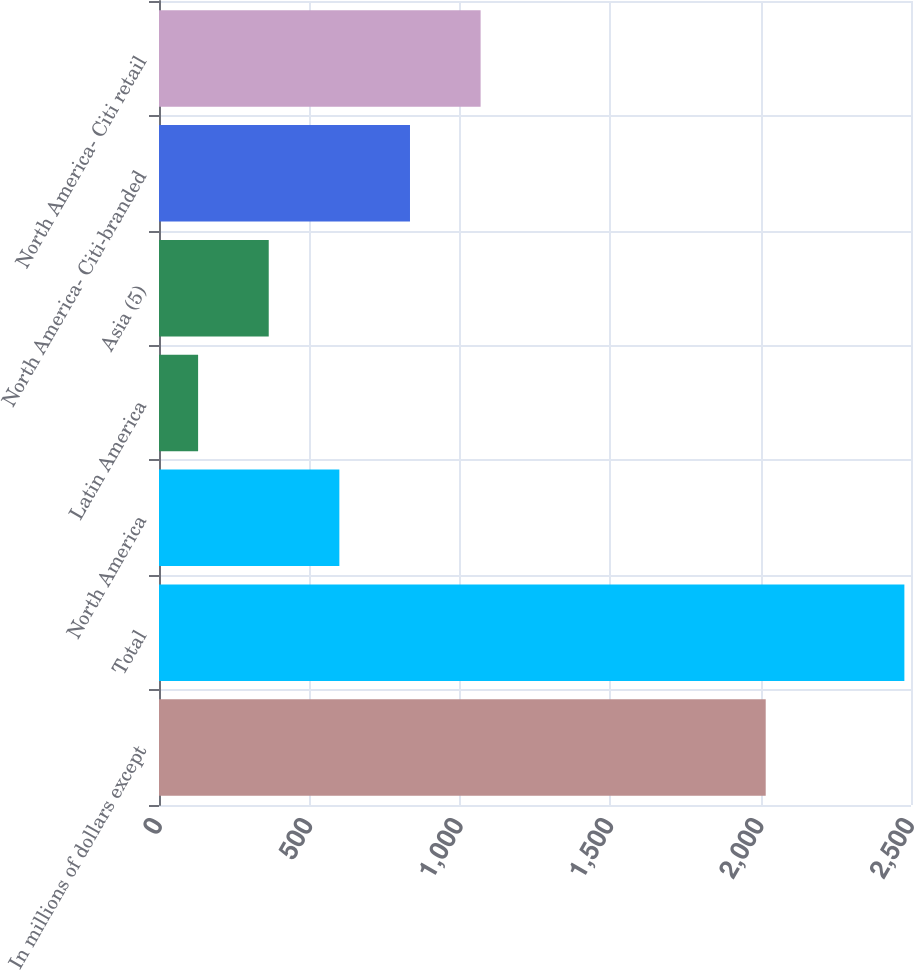<chart> <loc_0><loc_0><loc_500><loc_500><bar_chart><fcel>In millions of dollars except<fcel>Total<fcel>North America<fcel>Latin America<fcel>Asia (5)<fcel>North America- Citi-branded<fcel>North America- Citi retail<nl><fcel>2017<fcel>2478<fcel>599.6<fcel>130<fcel>364.8<fcel>834.4<fcel>1069.2<nl></chart> 